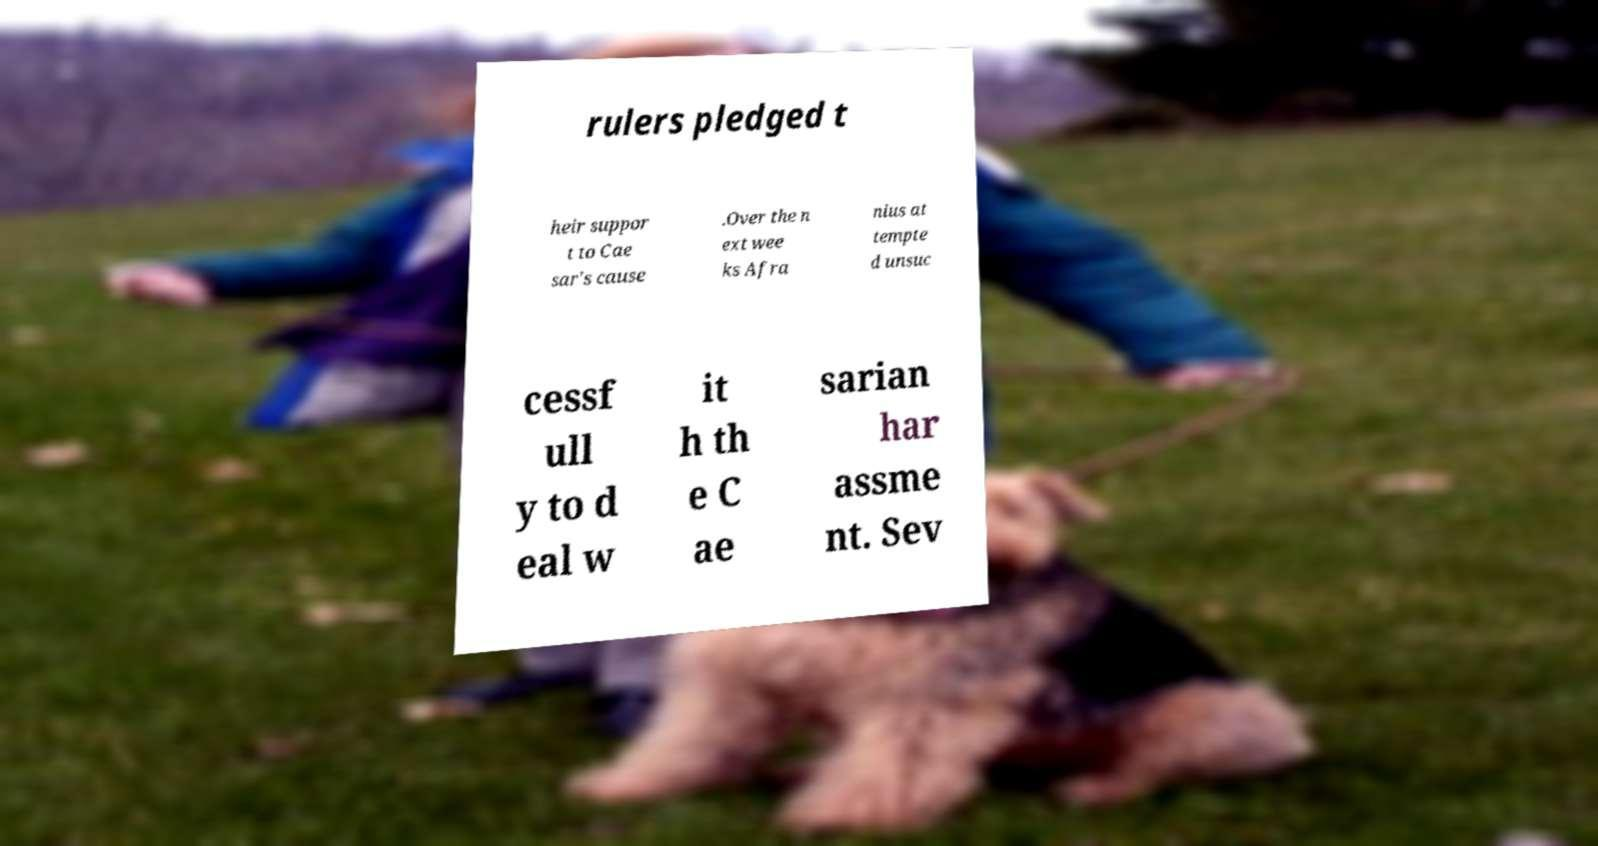I need the written content from this picture converted into text. Can you do that? rulers pledged t heir suppor t to Cae sar's cause .Over the n ext wee ks Afra nius at tempte d unsuc cessf ull y to d eal w it h th e C ae sarian har assme nt. Sev 